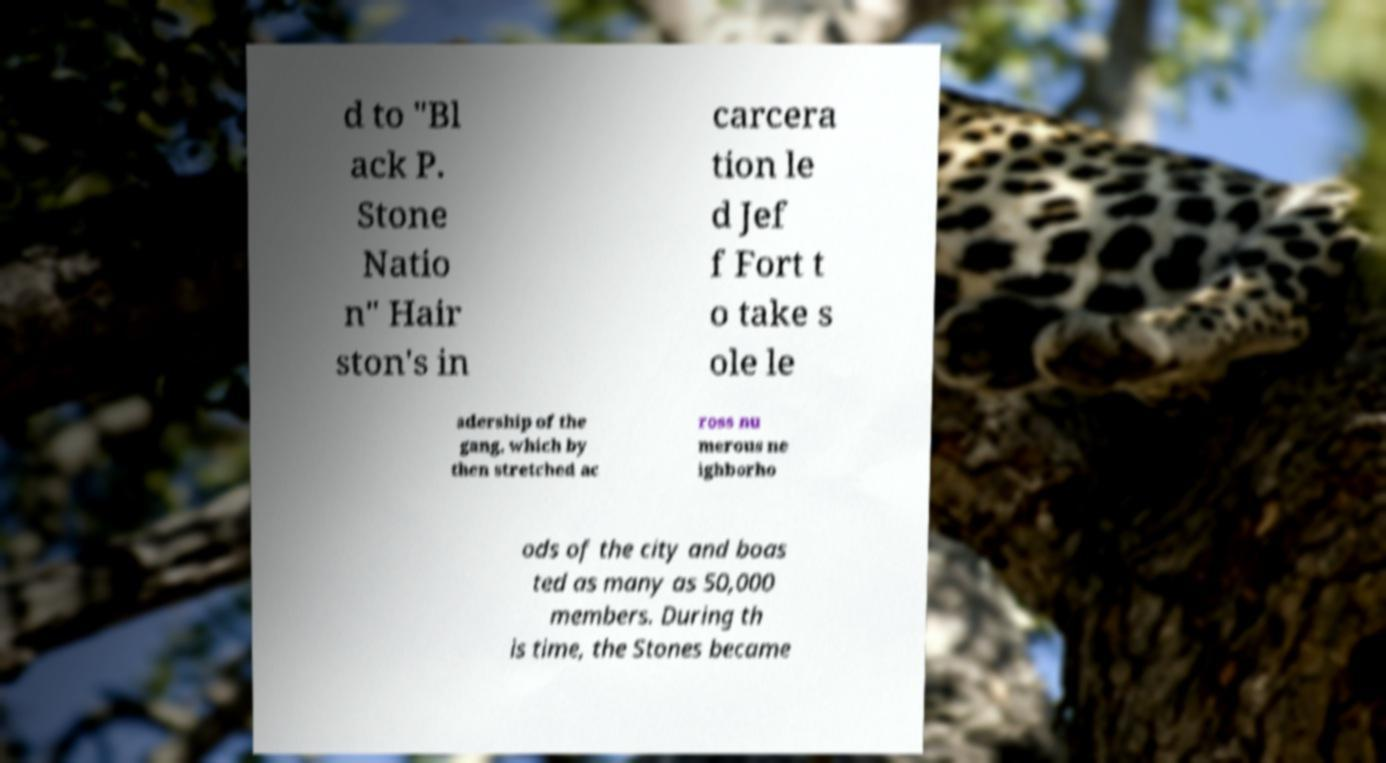Please identify and transcribe the text found in this image. d to "Bl ack P. Stone Natio n" Hair ston's in carcera tion le d Jef f Fort t o take s ole le adership of the gang, which by then stretched ac ross nu merous ne ighborho ods of the city and boas ted as many as 50,000 members. During th is time, the Stones became 